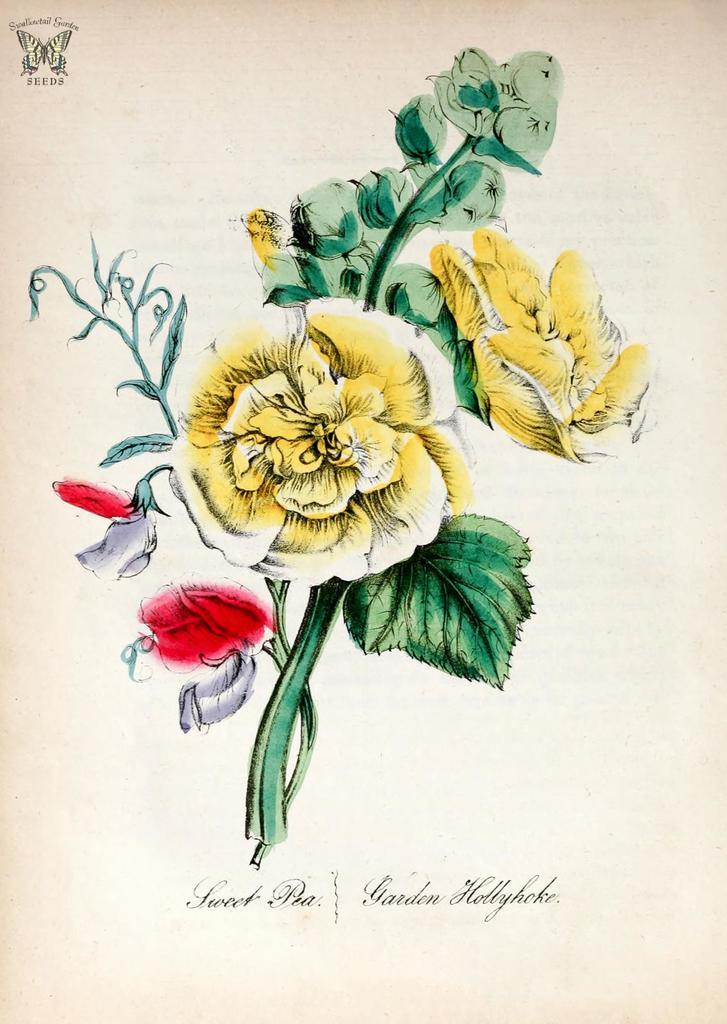What is the main subject of the image? The image contains a poster. What is depicted in the middle of the poster? There are flowers, leaves, and stems in the middle of the poster. Where is the text located on the poster? There is text at the bottom and top of the poster. What is present at the top of the poster? There is a logo at the top of the poster. How many legs can be seen on the goose in the image? There is no goose present in the image. What type of clover is depicted in the middle of the poster? There is no clover depicted in the middle of the poster; it features flowers, leaves, and stems. 